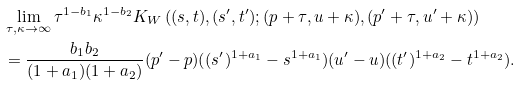<formula> <loc_0><loc_0><loc_500><loc_500>& \lim _ { \tau , \kappa \to \infty } \tau ^ { 1 - b _ { 1 } } \kappa ^ { 1 - b _ { 2 } } K _ { W } \left ( ( s , t ) , ( s ^ { \prime } , t ^ { \prime } ) ; ( p + \tau , u + \kappa ) , ( p ^ { \prime } + \tau , u ^ { \prime } + \kappa ) \right ) \\ & = \frac { b _ { 1 } b _ { 2 } } { ( 1 + a _ { 1 } ) ( 1 + a _ { 2 } ) } ( p ^ { \prime } - p ) ( ( s ^ { \prime } ) ^ { 1 + a _ { 1 } } - s ^ { 1 + a _ { 1 } } ) ( u ^ { \prime } - u ) ( ( t ^ { \prime } ) ^ { 1 + a _ { 2 } } - t ^ { 1 + a _ { 2 } } ) .</formula> 